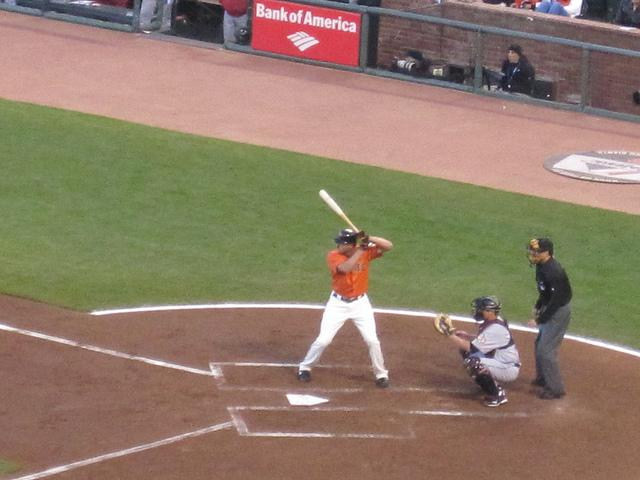What type of service sponsors this stadium? banking 